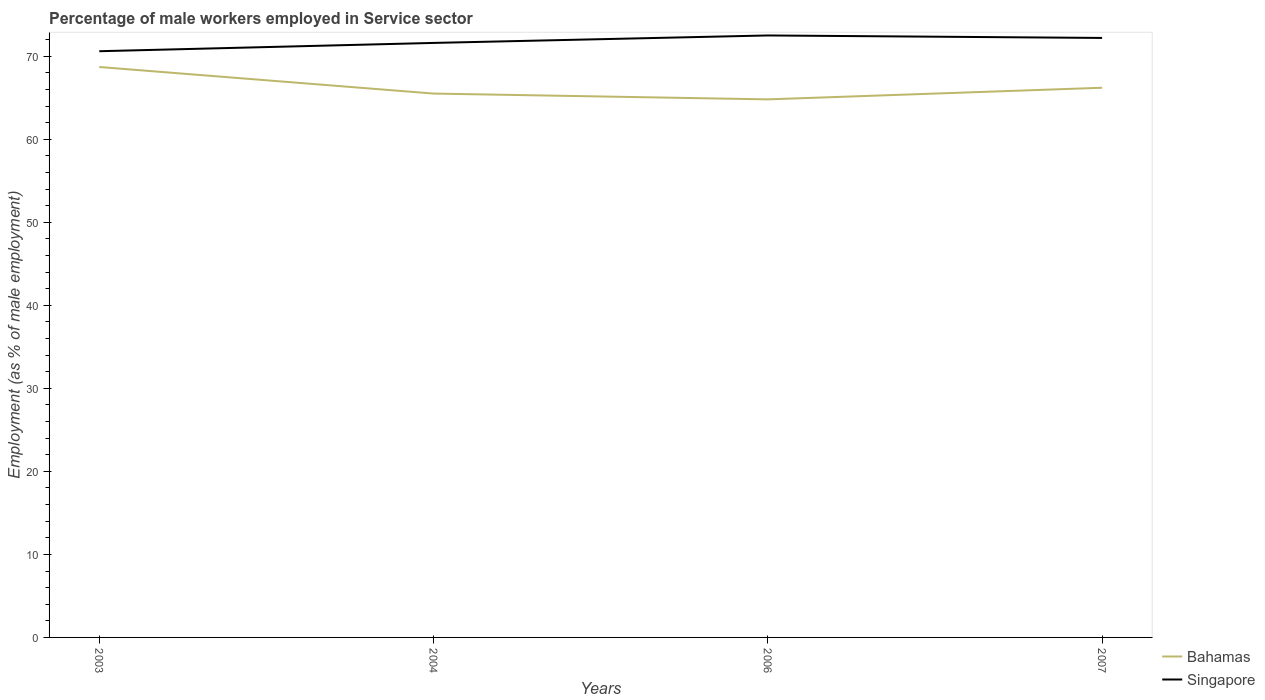Does the line corresponding to Bahamas intersect with the line corresponding to Singapore?
Make the answer very short. No. Across all years, what is the maximum percentage of male workers employed in Service sector in Singapore?
Offer a terse response. 70.6. What is the total percentage of male workers employed in Service sector in Singapore in the graph?
Your answer should be compact. -1. What is the difference between the highest and the second highest percentage of male workers employed in Service sector in Singapore?
Make the answer very short. 1.9. How many years are there in the graph?
Offer a terse response. 4. What is the difference between two consecutive major ticks on the Y-axis?
Your answer should be compact. 10. Where does the legend appear in the graph?
Offer a terse response. Bottom right. What is the title of the graph?
Provide a succinct answer. Percentage of male workers employed in Service sector. What is the label or title of the Y-axis?
Ensure brevity in your answer.  Employment (as % of male employment). What is the Employment (as % of male employment) of Bahamas in 2003?
Your response must be concise. 68.7. What is the Employment (as % of male employment) in Singapore in 2003?
Provide a short and direct response. 70.6. What is the Employment (as % of male employment) in Bahamas in 2004?
Your response must be concise. 65.5. What is the Employment (as % of male employment) of Singapore in 2004?
Offer a very short reply. 71.6. What is the Employment (as % of male employment) of Bahamas in 2006?
Your answer should be very brief. 64.8. What is the Employment (as % of male employment) of Singapore in 2006?
Ensure brevity in your answer.  72.5. What is the Employment (as % of male employment) of Bahamas in 2007?
Keep it short and to the point. 66.2. What is the Employment (as % of male employment) in Singapore in 2007?
Provide a succinct answer. 72.2. Across all years, what is the maximum Employment (as % of male employment) in Bahamas?
Your answer should be compact. 68.7. Across all years, what is the maximum Employment (as % of male employment) in Singapore?
Provide a short and direct response. 72.5. Across all years, what is the minimum Employment (as % of male employment) in Bahamas?
Make the answer very short. 64.8. Across all years, what is the minimum Employment (as % of male employment) in Singapore?
Provide a succinct answer. 70.6. What is the total Employment (as % of male employment) in Bahamas in the graph?
Offer a terse response. 265.2. What is the total Employment (as % of male employment) in Singapore in the graph?
Your answer should be very brief. 286.9. What is the difference between the Employment (as % of male employment) in Singapore in 2003 and that in 2006?
Keep it short and to the point. -1.9. What is the difference between the Employment (as % of male employment) of Singapore in 2003 and that in 2007?
Give a very brief answer. -1.6. What is the difference between the Employment (as % of male employment) of Singapore in 2006 and that in 2007?
Provide a succinct answer. 0.3. What is the difference between the Employment (as % of male employment) in Bahamas in 2003 and the Employment (as % of male employment) in Singapore in 2006?
Give a very brief answer. -3.8. What is the difference between the Employment (as % of male employment) of Bahamas in 2004 and the Employment (as % of male employment) of Singapore in 2006?
Your response must be concise. -7. What is the average Employment (as % of male employment) of Bahamas per year?
Your answer should be very brief. 66.3. What is the average Employment (as % of male employment) in Singapore per year?
Keep it short and to the point. 71.72. In the year 2006, what is the difference between the Employment (as % of male employment) in Bahamas and Employment (as % of male employment) in Singapore?
Your response must be concise. -7.7. What is the ratio of the Employment (as % of male employment) of Bahamas in 2003 to that in 2004?
Your response must be concise. 1.05. What is the ratio of the Employment (as % of male employment) in Singapore in 2003 to that in 2004?
Your response must be concise. 0.99. What is the ratio of the Employment (as % of male employment) of Bahamas in 2003 to that in 2006?
Your answer should be compact. 1.06. What is the ratio of the Employment (as % of male employment) in Singapore in 2003 to that in 2006?
Make the answer very short. 0.97. What is the ratio of the Employment (as % of male employment) of Bahamas in 2003 to that in 2007?
Your answer should be compact. 1.04. What is the ratio of the Employment (as % of male employment) of Singapore in 2003 to that in 2007?
Keep it short and to the point. 0.98. What is the ratio of the Employment (as % of male employment) in Bahamas in 2004 to that in 2006?
Provide a succinct answer. 1.01. What is the ratio of the Employment (as % of male employment) in Singapore in 2004 to that in 2006?
Your answer should be compact. 0.99. What is the ratio of the Employment (as % of male employment) of Singapore in 2004 to that in 2007?
Your answer should be very brief. 0.99. What is the ratio of the Employment (as % of male employment) of Bahamas in 2006 to that in 2007?
Make the answer very short. 0.98. 